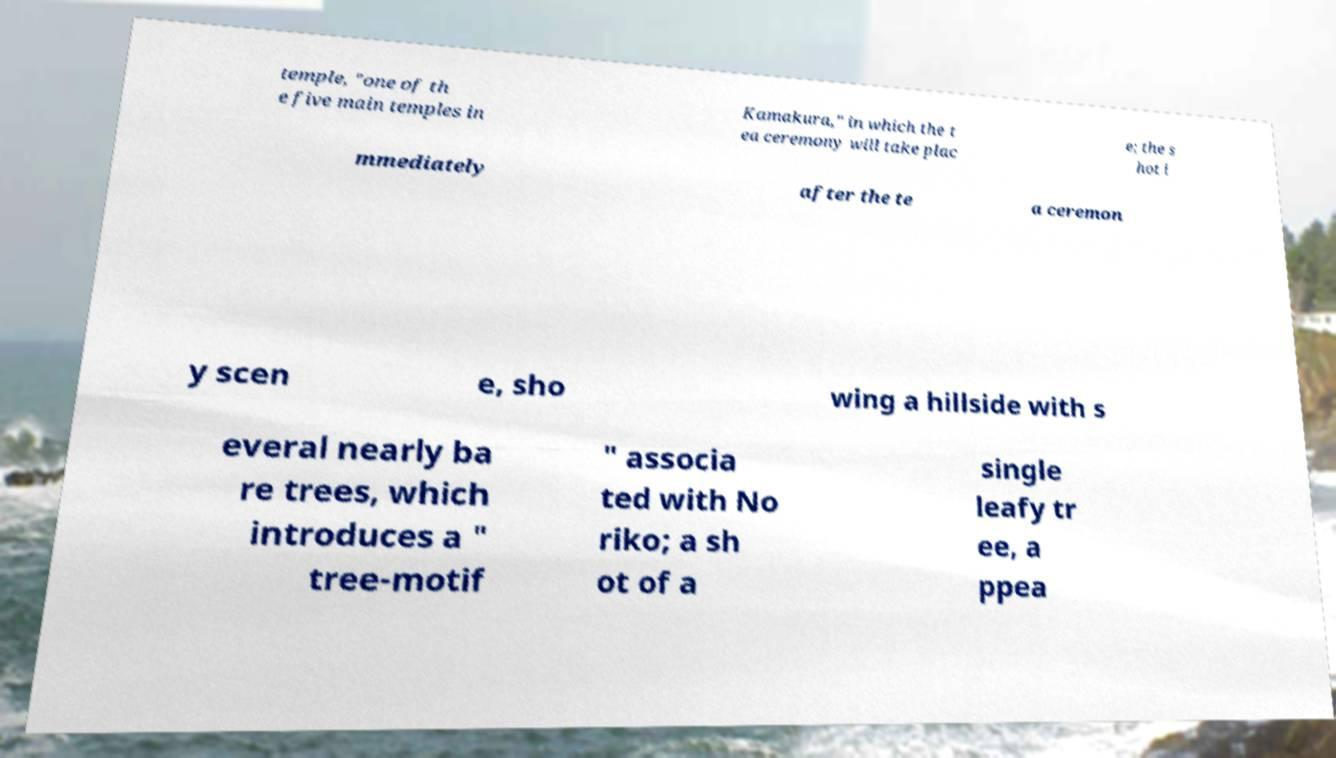I need the written content from this picture converted into text. Can you do that? temple, "one of th e five main temples in Kamakura," in which the t ea ceremony will take plac e; the s hot i mmediately after the te a ceremon y scen e, sho wing a hillside with s everal nearly ba re trees, which introduces a " tree-motif " associa ted with No riko; a sh ot of a single leafy tr ee, a ppea 